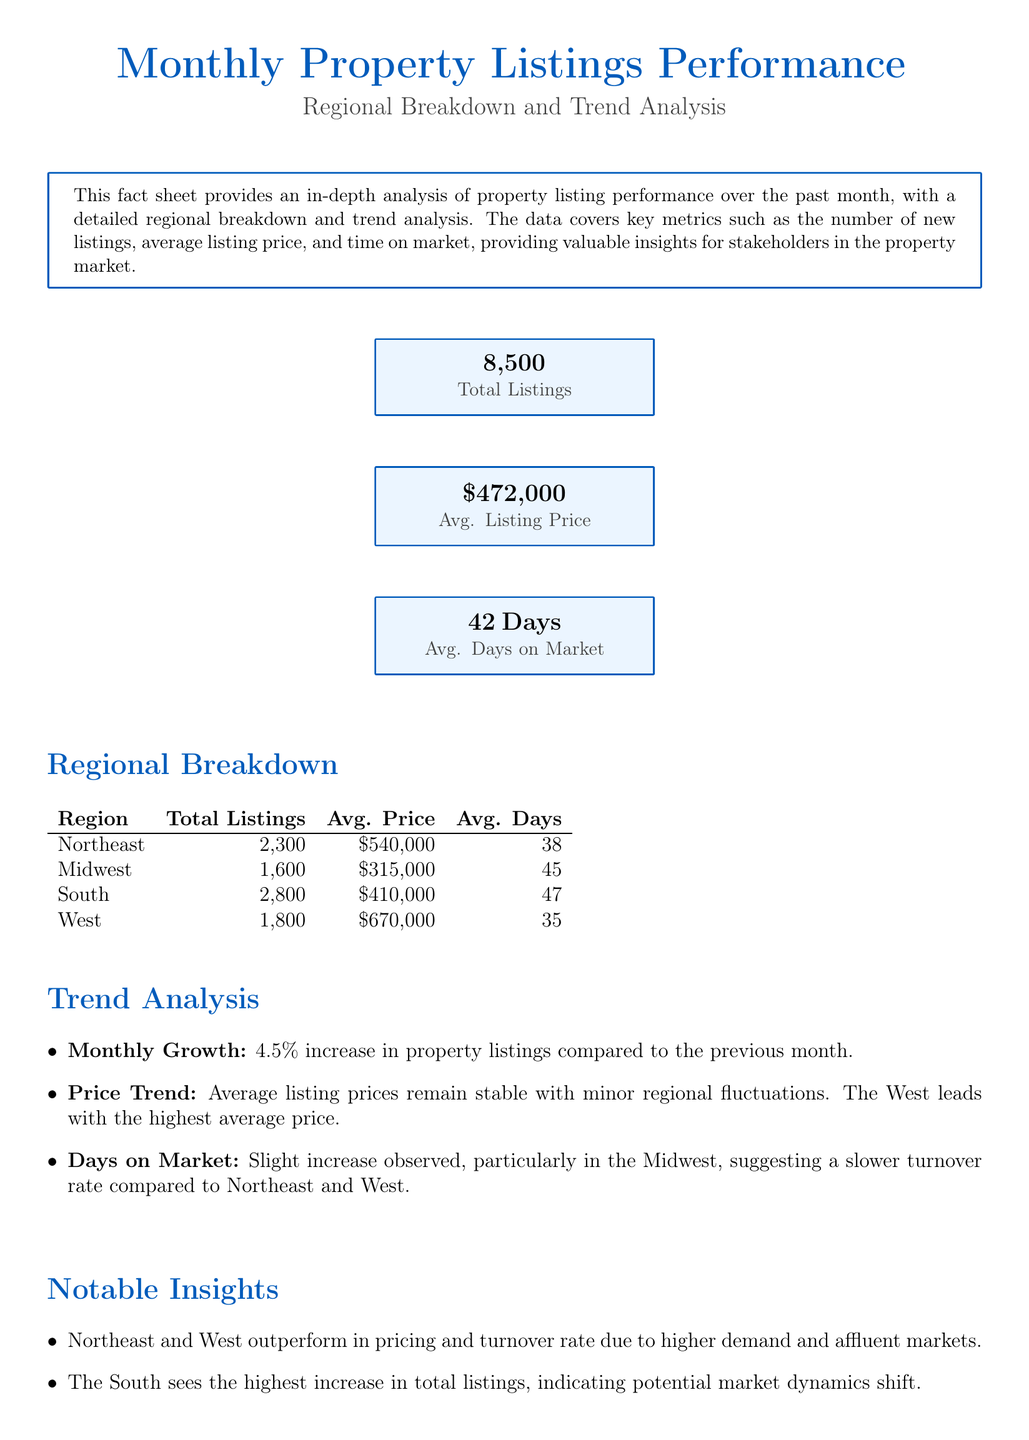What is the total number of property listings? The total number of property listings is indicated in the KPI section of the document.
Answer: 8,500 What is the average listing price in the Midwest? The average listing price for the Midwest can be found in the Regional Breakdown table.
Answer: $315,000 How many average days on market are observed in the West? The average days on market for the West region is specified in the Regional Breakdown table.
Answer: 35 Days What is the percentage growth in property listings this month? The document states a 4.5% increase in property listings compared to the previous month.
Answer: 4.5% Which region has the highest average listing price? The trend analysis indicates that the West region leads with the highest average price.
Answer: West What notable insight is related to the Midwest region? The notable insights section mentions a specific observation about the Midwest's market conditions.
Answer: Higher average days on market What is the average listing price for the South? The average listing price for the South is included in the Regional Breakdown.
Answer: $410,000 What is the main conclusion of the fact sheet? The conclusion section summarizes the overall assessment of the market based on the data provided.
Answer: Healthy growth with regional variances 